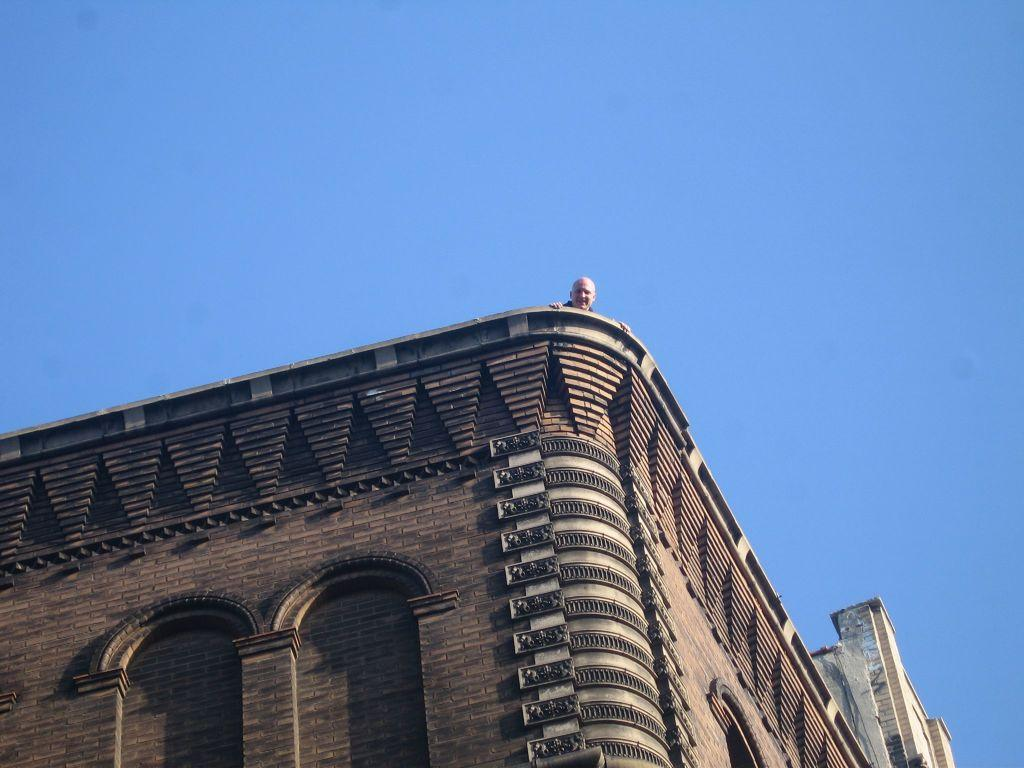What is the person in the image doing? The person in the image is on the top of a building. What is the color of the building? The building is brown in color. How does the snake react to the visitor in the image? There is no snake present in the image. What type of shock does the person on the building experience in the image? There is no indication of any shock experienced by the person in the image. 